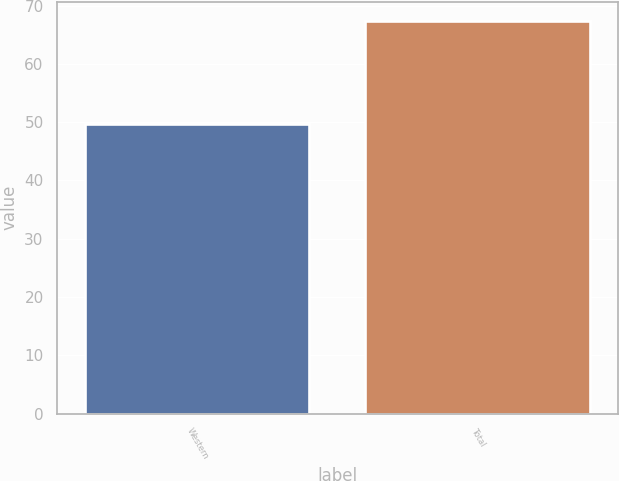<chart> <loc_0><loc_0><loc_500><loc_500><bar_chart><fcel>Western<fcel>Total<nl><fcel>49.6<fcel>67.3<nl></chart> 